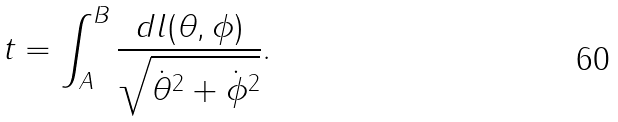<formula> <loc_0><loc_0><loc_500><loc_500>t = \int _ { A } ^ { B } { \frac { d l ( \theta , \phi ) } { \sqrt { \dot { \theta } ^ { 2 } + \dot { \phi } ^ { 2 } } } } .</formula> 